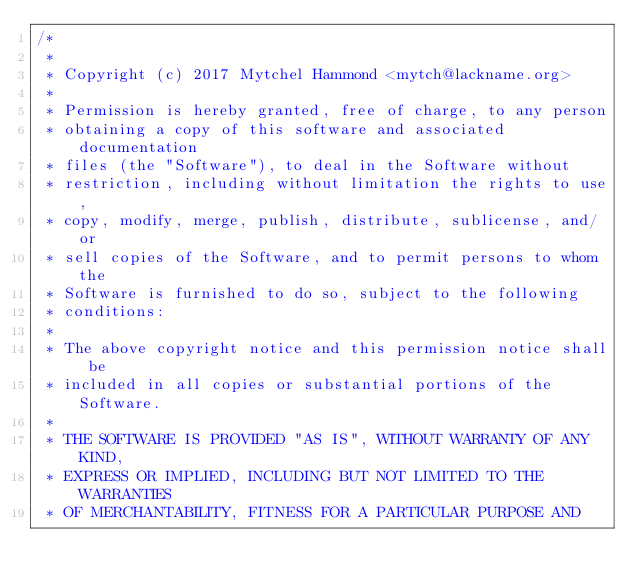Convert code to text. <code><loc_0><loc_0><loc_500><loc_500><_C_>/*
 *
 * Copyright (c) 2017 Mytchel Hammond <mytch@lackname.org>
 * 
 * Permission is hereby granted, free of charge, to any person
 * obtaining a copy of this software and associated documentation
 * files (the "Software"), to deal in the Software without
 * restriction, including without limitation the rights to use,
 * copy, modify, merge, publish, distribute, sublicense, and/or
 * sell copies of the Software, and to permit persons to whom the
 * Software is furnished to do so, subject to the following
 * conditions:
 * 
 * The above copyright notice and this permission notice shall be
 * included in all copies or substantial portions of the Software.
 * 
 * THE SOFTWARE IS PROVIDED "AS IS", WITHOUT WARRANTY OF ANY KIND,
 * EXPRESS OR IMPLIED, INCLUDING BUT NOT LIMITED TO THE WARRANTIES
 * OF MERCHANTABILITY, FITNESS FOR A PARTICULAR PURPOSE AND</code> 